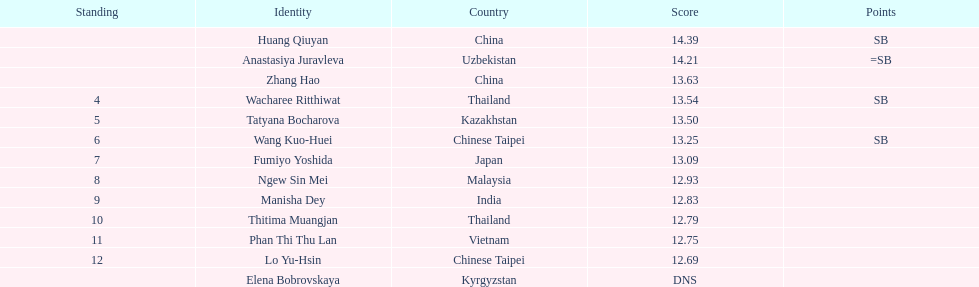How many people were ranked? 12. 